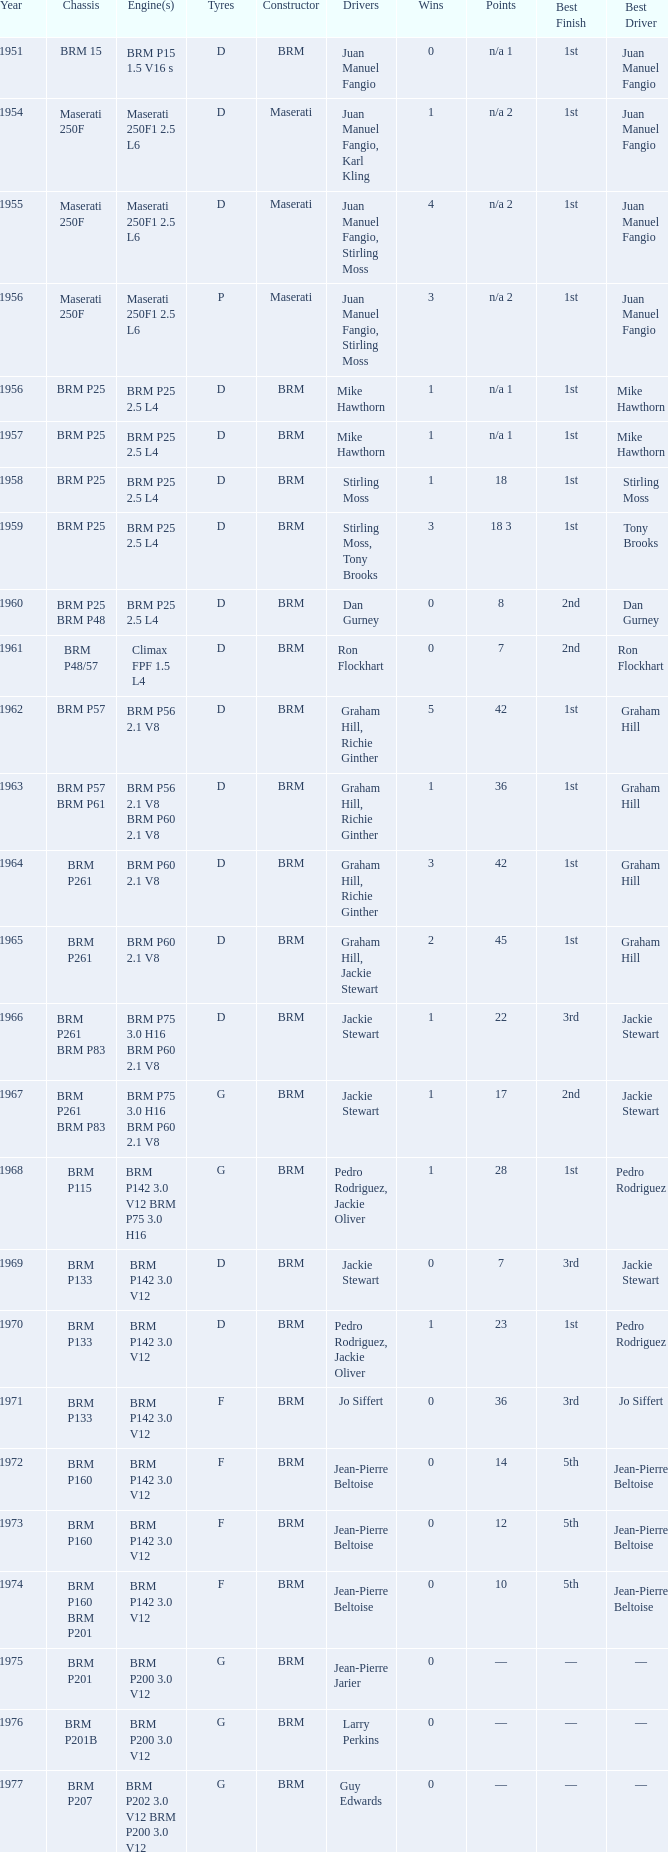Name the chassis for 1970 and tyres of d BRM P133. 